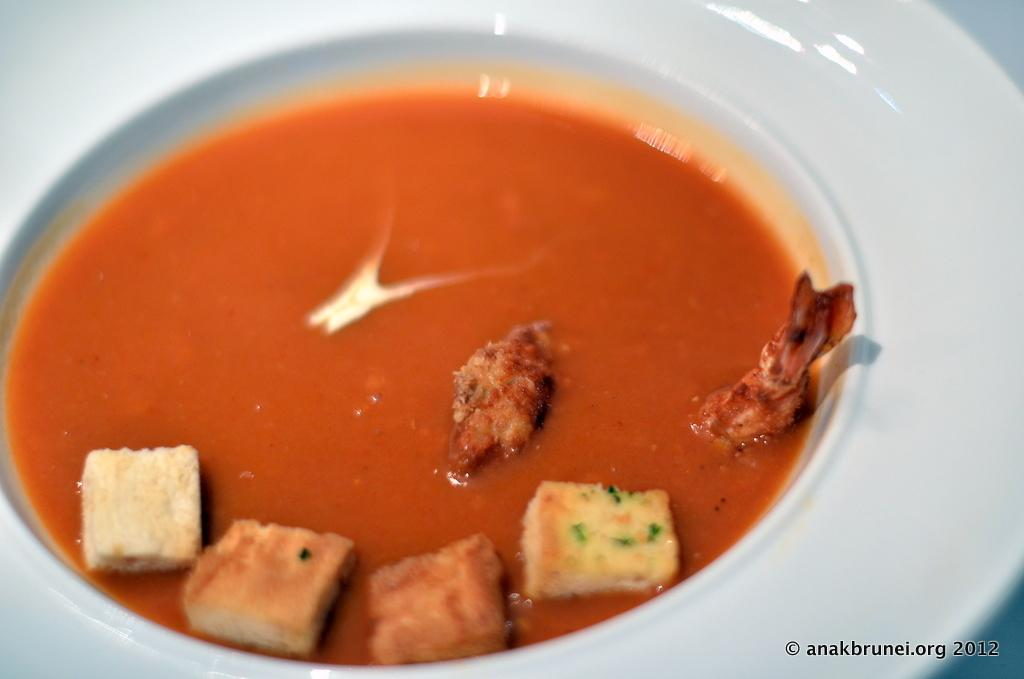What is in the bowl that is visible in the image? The bowl contains a food item. Can you describe the food item in the bowl? Unfortunately, the specific food item cannot be determined from the provided facts. What is present in the bottom right corner of the image? There is edited text in the bottom right corner of the image. What type of jeans is being worn by the person sitting on the seat in the image? There is no person or seat present in the image, so it is not possible to determine what type of jeans they might be wearing. 